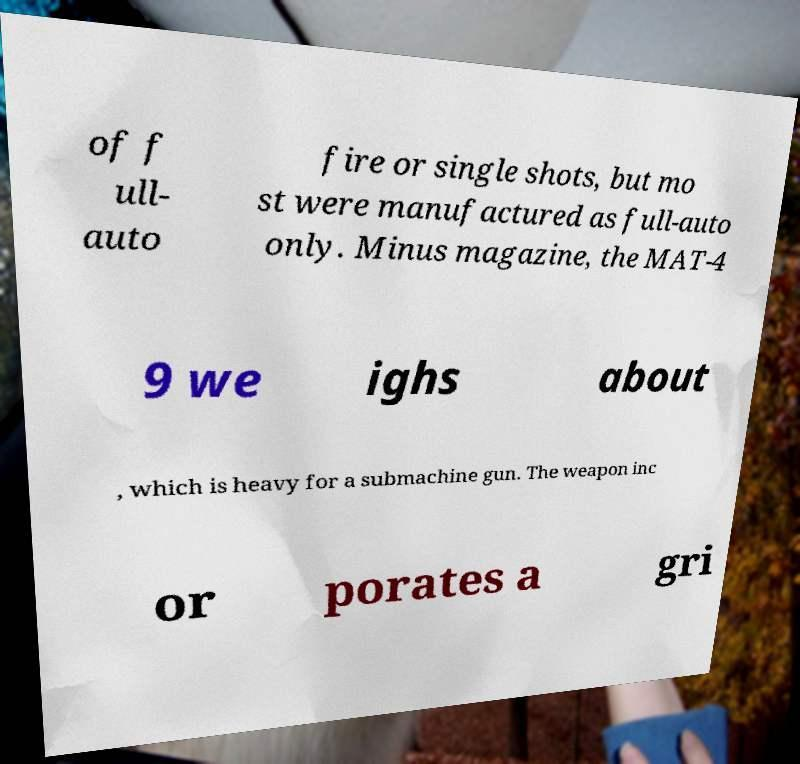What messages or text are displayed in this image? I need them in a readable, typed format. of f ull- auto fire or single shots, but mo st were manufactured as full-auto only. Minus magazine, the MAT-4 9 we ighs about , which is heavy for a submachine gun. The weapon inc or porates a gri 